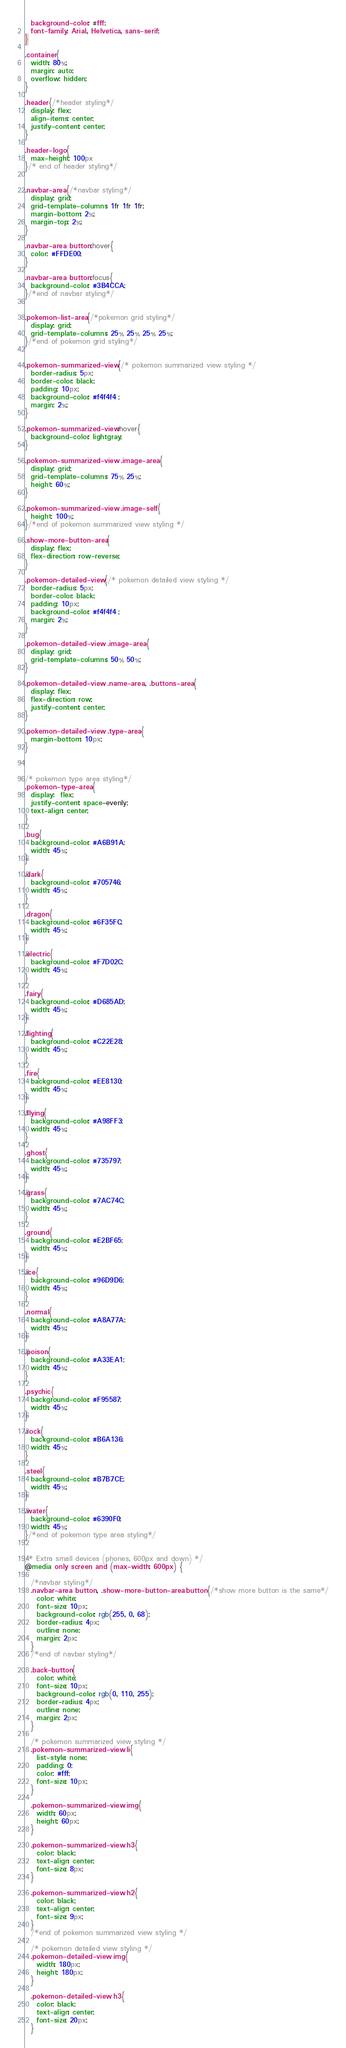<code> <loc_0><loc_0><loc_500><loc_500><_CSS_>  background-color: #fff;
  font-family: Arial, Helvetica, sans-serif;
}

.container{
  width: 80%;
  margin: auto;
  overflow: hidden;
}

.header{/*header styling*/
  display: flex;
  align-items: center;
  justify-content: center;
}

.header-logo{
  max-height: 100px
}/* end of header styling*/


.navbar-area{/*navbar styling*/
  display: grid;
  grid-template-columns: 1fr 1fr 1fr;
  margin-bottom: 2%;
  margin-top: 2%;
}

.navbar-area button:hover{
  color: #FFDE00;
}

.navbar-area button:focus{
  background-color: #3B4CCA;
}/*end of navbar styling*/


.pokemon-list-area{/*pokemon grid styling*/
  display: grid;
  grid-template-columns: 25% 25% 25% 25%;
}/*end of pokemon grid styling*/


.pokemon-summarized-view{/* pokemon summarized view styling */
  border-radius: 5px;
  border-color: black;
  padding: 10px;
  background-color: #f4f4f4 ;
  margin: 2%;
}

.pokemon-summarized-view:hover{
  background-color: lightgray;
}

.pokemon-summarized-view .image-area{
  display: grid;
  grid-template-columns: 75% 25%;
  height: 60%;
}

.pokemon-summarized-view .image-self{
  height: 100%;
}/*end of pokemon summarized view styling */

.show-more-button-area{
  display: flex;
  flex-direction: row-reverse;
}

.pokemon-detailed-view{/* pokemon detailed view styling */
  border-radius: 5px;
  border-color: black;
  padding: 10px;
  background-color: #f4f4f4 ;
  margin: 2%;
}

.pokemon-detailed-view .image-area{
  display: grid;
  grid-template-columns: 50% 50%;
}

.pokemon-detailed-view .name-area, .buttons-area{
  display: flex;
  flex-direction: row;
  justify-content: center;
}

.pokemon-detailed-view .type-area{
  margin-bottom: 10px;
}



/* pokemon type area styling*/
.pokemon-type-area{
  display:  flex;
  justify-content: space-evenly;
  text-align: center;
}

.bug{
  background-color: #A6B91A;
  width: 45%;
}

.dark{
  background-color: #705746;
  width: 45%;
}

.dragon{
  background-color: #6F35FC;
  width: 45%;
}

.electric{
  background-color: #F7D02C;
  width: 45%;
}

.fairy{
  background-color: #D685AD;
  width: 45%;
}

.fighting{
  background-color: #C22E28;
  width: 45%;
}

.fire{
  background-color: #EE8130;
  width: 45%;
}

.flying{
  background-color: #A98FF3;
  width: 45%;
}

.ghost{
  background-color: #735797;
  width: 45%;
}

.grass{
  background-color: #7AC74C;
  width: 45%;
}

.ground{
  background-color: #E2BF65;
  width: 45%;
}

.ice{
  background-color: #96D9D6;
  width: 45%;
}

.normal{
  background-color: #A8A77A;
  width: 45%;
}

.poison{
  background-color: #A33EA1;
  width: 45%;
}

.psychic{
  background-color: #F95587;
  width: 45%;
}

.rock{
  background-color: #B6A136;
  width: 45%;
}

.steel{
  background-color: #B7B7CE;
  width: 45%;
}

.water{
  background-color: #6390F0;
  width: 45%;
}/*end of pokemon type area styling*/


/* Extra small devices (phones, 600px and down) */
@media only screen and (max-width: 600px) {

  /*navbar styling*/
  .navbar-area button, .show-more-button-area button{/*show more button is the same*/
    color: white;
    font-size: 10px;
    background-color: rgb(255, 0, 68);
    border-radius: 4px;
    outline: none;
    margin: 2px;
  }
  /*end of navbar styling*/

  .back-button{
    color: white;
    font-size: 10px;
    background-color: rgb(0, 110, 255);
    border-radius: 4px;
    outline: none;
    margin: 2px;
  }

  /* pokemon summarized view styling */
  .pokemon-summarized-view li{
    list-style: none;
    padding: 0;
    color: #fff;
    font-size: 10px;
  }

  .pokemon-summarized-view img{
    width: 60px;
    height: 60px;
  }

  .pokemon-summarized-view h3{
    color: black;
    text-align: center;
    font-size: 8px;
  }

  .pokemon-summarized-view h2{
    color: black;
    text-align: center;
    font-size: 9px;
  }
  /*end of pokemon summarized view styling */
  
  /* pokemon detailed view styling */
  .pokemon-detailed-view img{
    width: 180px;
    height: 180px;
  }

  .pokemon-detailed-view h3{
    color: black;
    text-align: center;
    font-size: 20px;
  }
</code> 